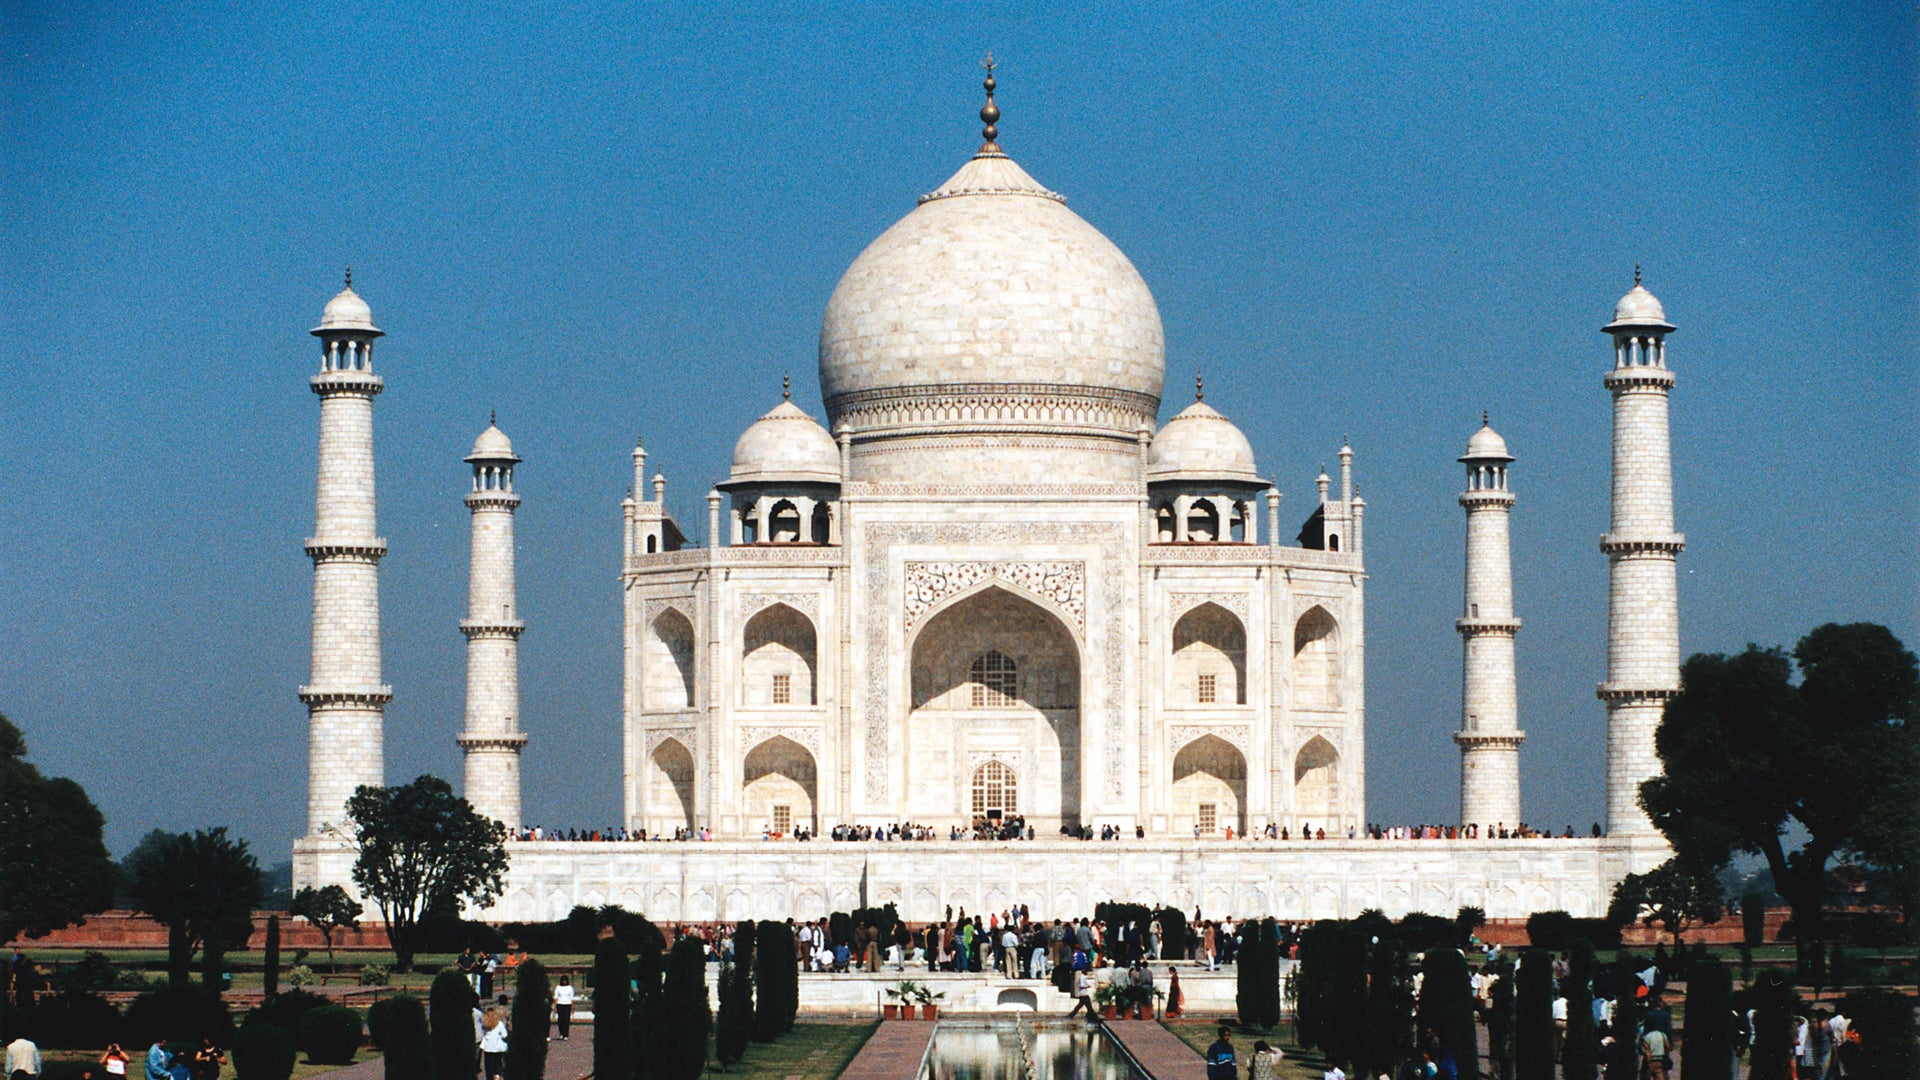What historical significance does this monument hold? The Taj Mahal holds immense historical significance as it represents the zenith of Mughal architecture and is a symbol of India's rich heritage. Constructed between 1632 and 1653, it commemorates the love of Emperor Shah Jahan for his wife Mumtaz Mahal and serves as her final resting place, alongside the emperor himself. This edifice has been a UNESCO World Heritage Site since 1983 and is considered one of the universally admired masterpieces of the world's heritage. 